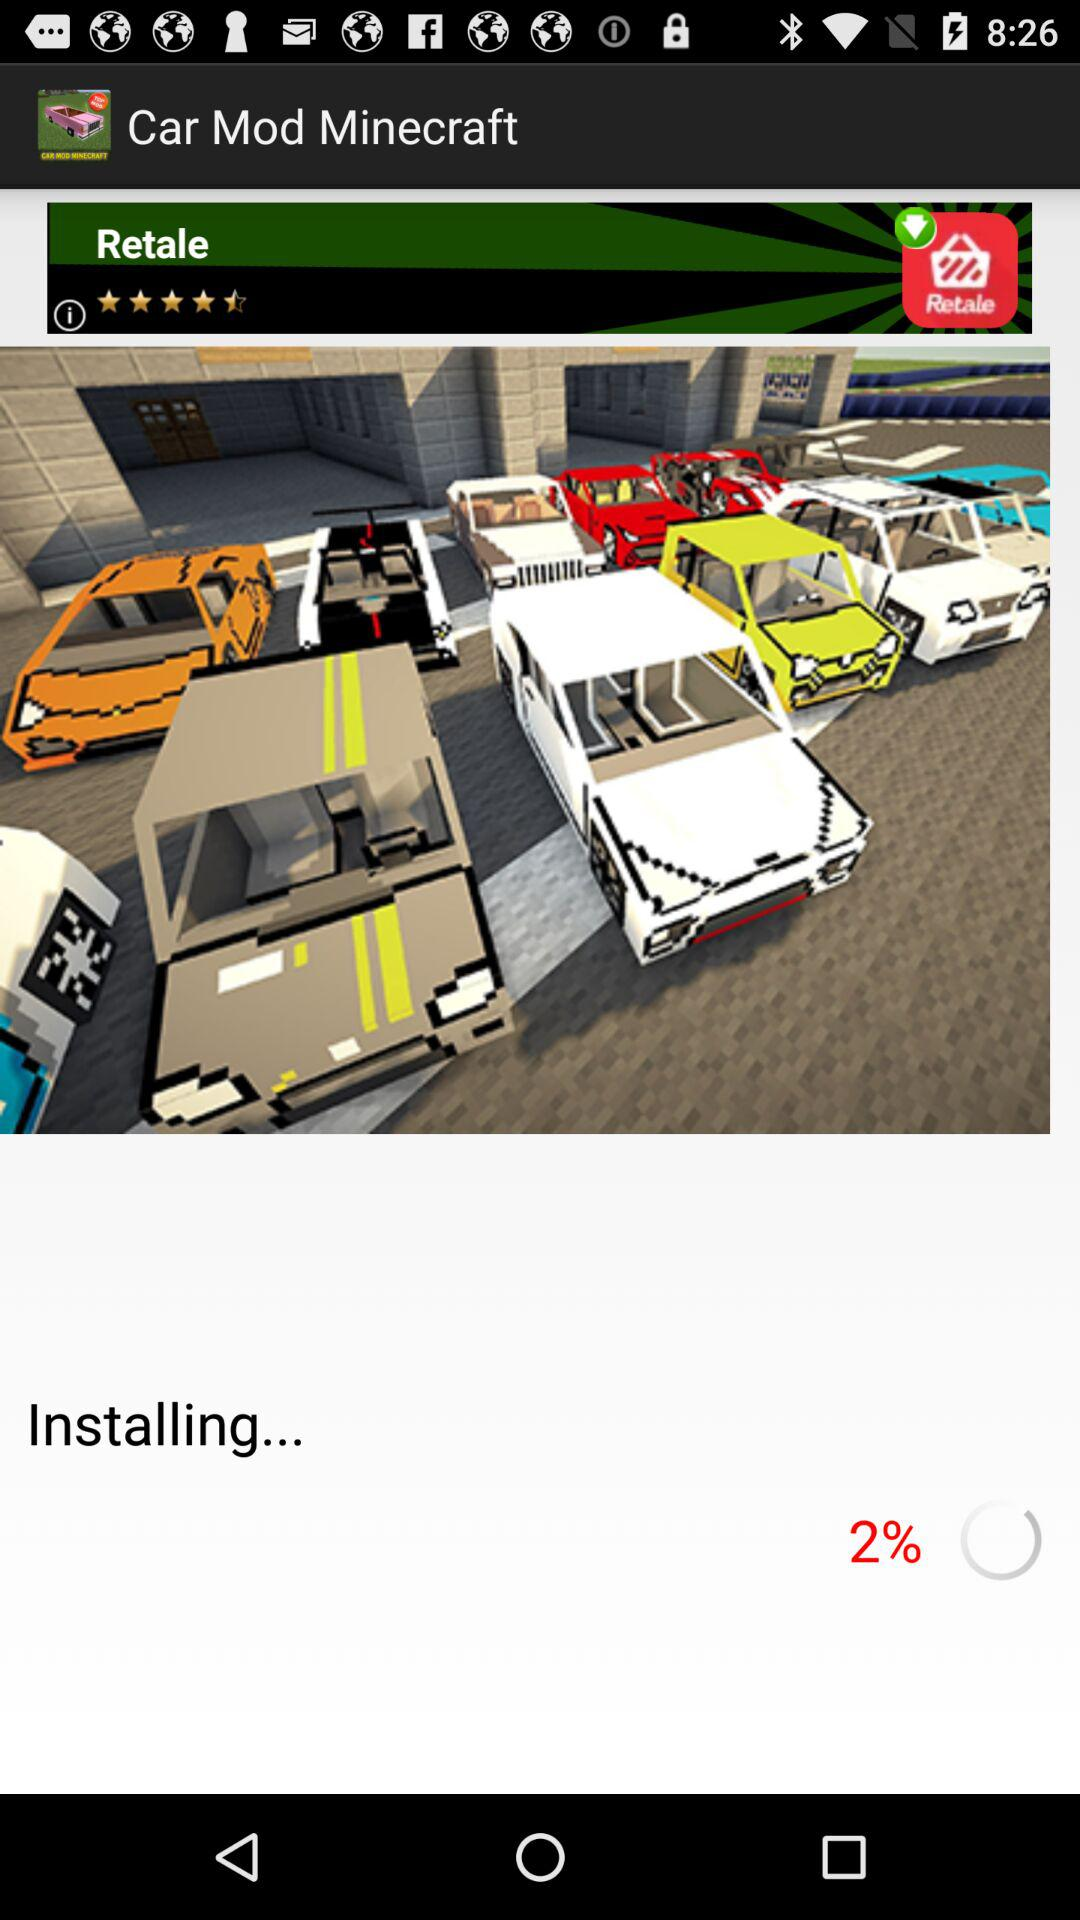How many percent of the app is installed?
Answer the question using a single word or phrase. 2% 